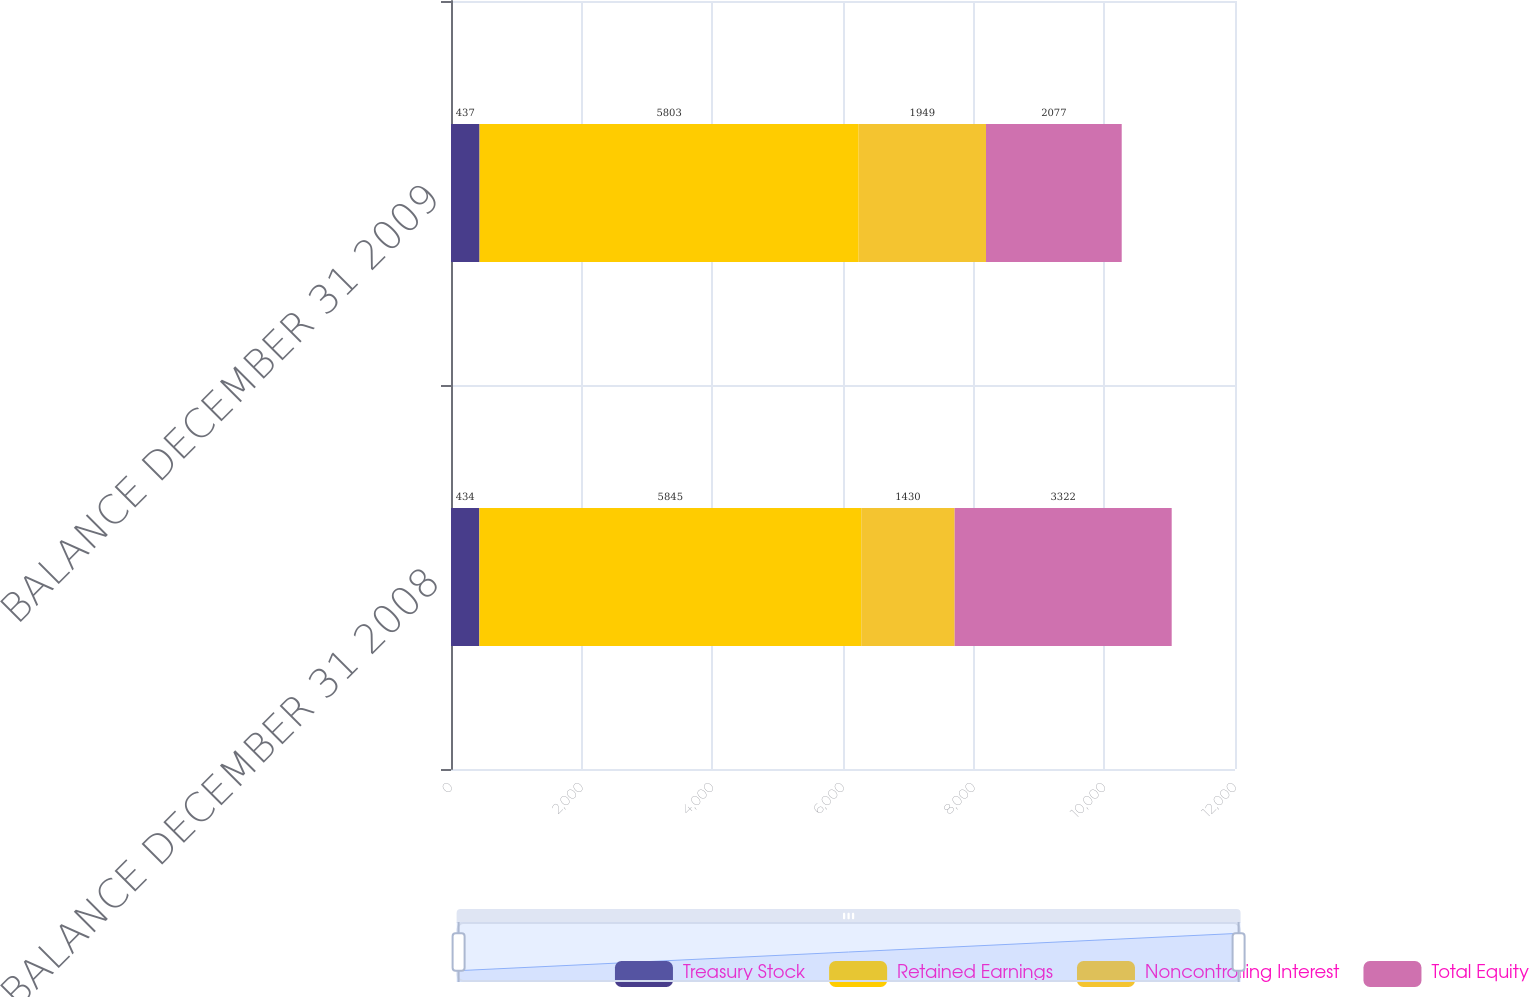Convert chart to OTSL. <chart><loc_0><loc_0><loc_500><loc_500><stacked_bar_chart><ecel><fcel>BALANCE DECEMBER 31 2008<fcel>BALANCE DECEMBER 31 2009<nl><fcel>Treasury Stock<fcel>434<fcel>437<nl><fcel>Retained Earnings<fcel>5845<fcel>5803<nl><fcel>Noncontrolling Interest<fcel>1430<fcel>1949<nl><fcel>Total Equity<fcel>3322<fcel>2077<nl></chart> 